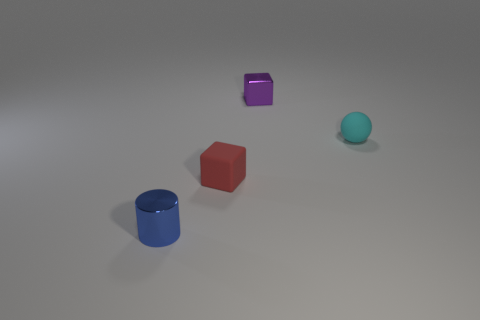Are there the same number of metal objects that are right of the sphere and tiny cyan things behind the small blue metal thing?
Your response must be concise. No. What is the color of the metallic thing that is right of the small block on the left side of the metal thing behind the small blue thing?
Provide a short and direct response. Purple. What is the shape of the purple metallic thing on the right side of the red block?
Make the answer very short. Cube. What shape is the object that is the same material as the small blue cylinder?
Provide a short and direct response. Cube. Is there any other thing that is the same shape as the tiny cyan matte thing?
Offer a terse response. No. How many cyan things are on the left side of the matte sphere?
Offer a terse response. 0. Are there the same number of red things that are to the left of the tiny cylinder and metal objects?
Keep it short and to the point. No. Is the material of the tiny purple cube the same as the blue thing?
Ensure brevity in your answer.  Yes. There is a thing that is in front of the tiny purple shiny cube and behind the small red block; what size is it?
Offer a very short reply. Small. What number of metallic cubes are the same size as the purple thing?
Offer a very short reply. 0. 